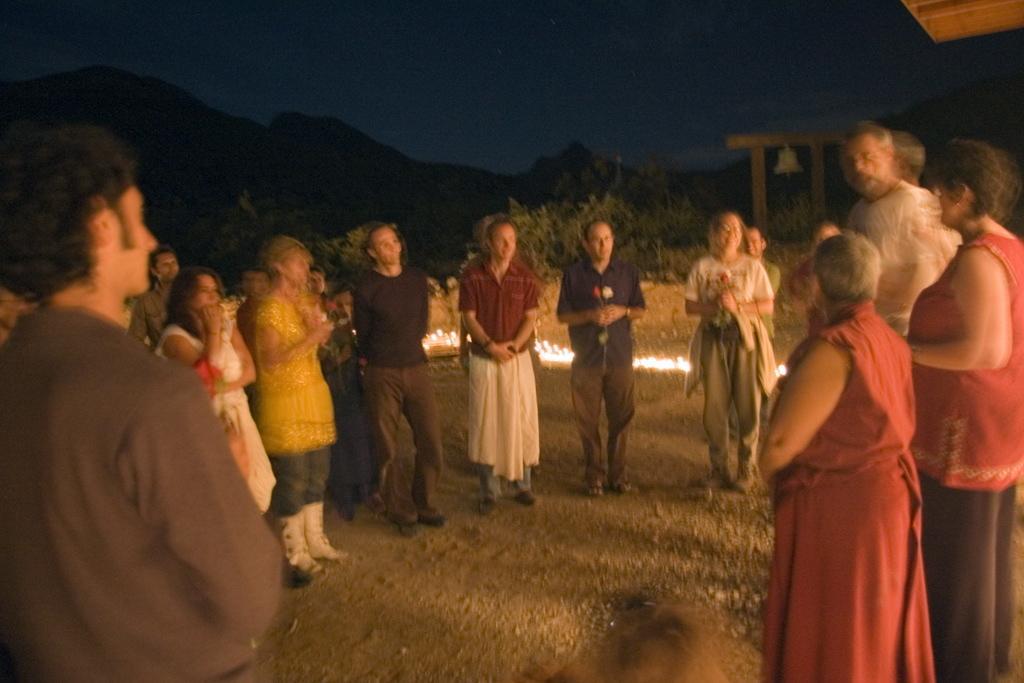Could you give a brief overview of what you see in this image? In this picture we can see some people are standing, at the bottom we can see some stones, in the background there are some plants and a bell, it looks like a hill on the left side there is the sky at the top of the picture, we can also see some lights at the bottom. 